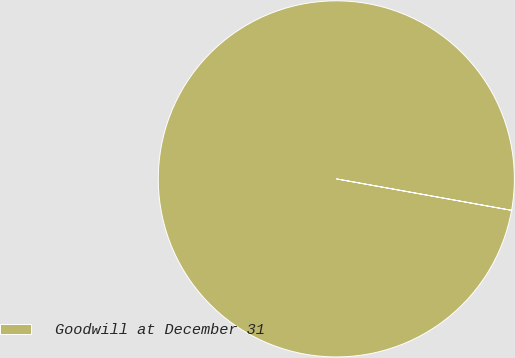Convert chart. <chart><loc_0><loc_0><loc_500><loc_500><pie_chart><fcel>Goodwill at December 31<nl><fcel>100.0%<nl></chart> 